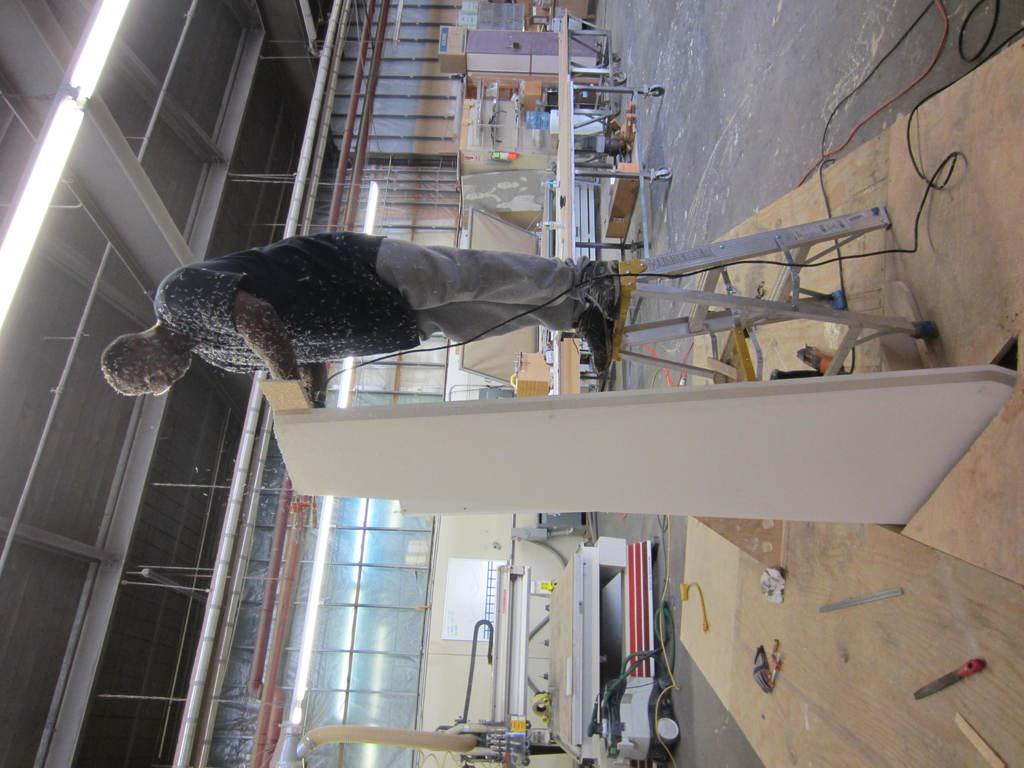What is the person in the image doing? The person is standing on a ladder in the image. What is the person holding while on the ladder? The person is holding a board. What type of furniture can be seen on the floor in the image? There are tables on the floor in the image. What else can be seen on the floor besides tables? There are machines on the floor in the image. What is attached to the roof in the left top area of the image? There are lights attached to the roof in the left top area of the image. What type of dress is the person wearing in the image? There is no information about the person's clothing in the image, so we cannot determine the type of dress they are wearing. Is the person using a quill to write on the board in the image? There is no quill or writing activity visible in the image. 